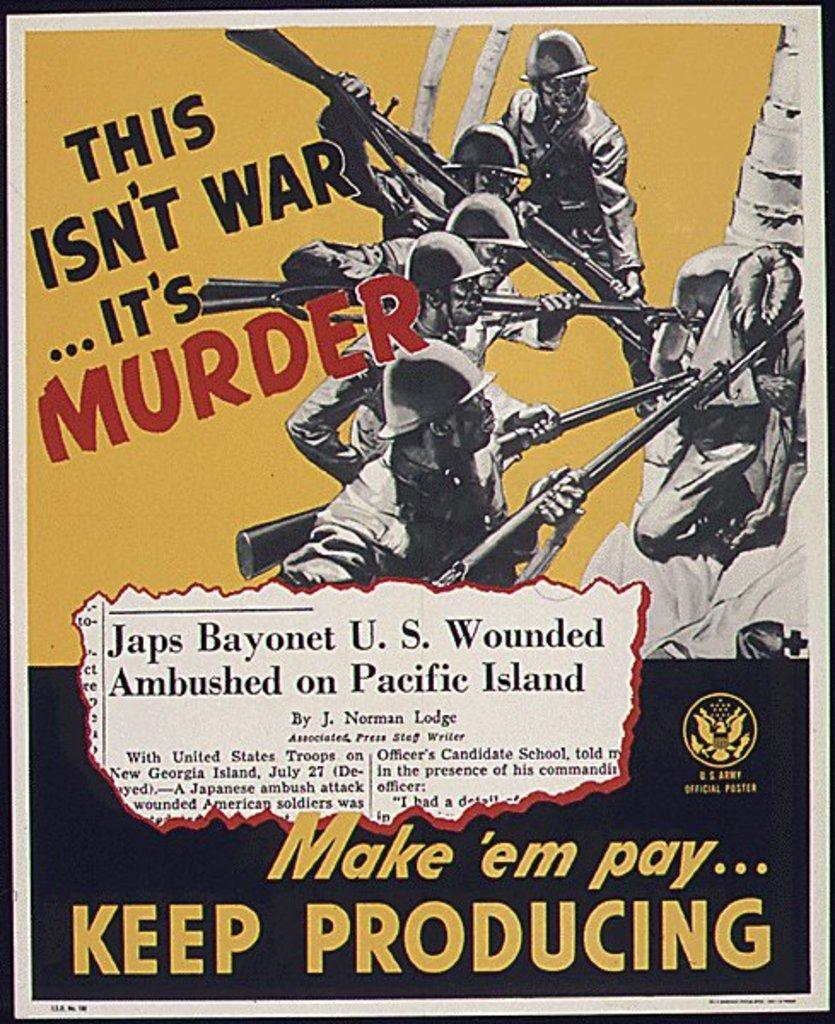<image>
Write a terse but informative summary of the picture. A WW II propaganda poster with Make 'em pay... written on it. 